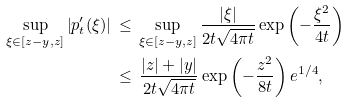Convert formula to latex. <formula><loc_0><loc_0><loc_500><loc_500>\sup _ { \xi \in [ z - y , z ] } \left | p _ { t } ^ { \prime } ( \xi ) \right | \, & \leq \, \sup _ { \xi \in [ z - y , z ] } \frac { | \xi | } { 2 t \sqrt { 4 \pi t } } \exp \left ( - \frac { \xi ^ { 2 } } { 4 t } \right ) \\ & \leq \, \frac { | z | + | y | } { 2 t \sqrt { 4 \pi t } } \exp \left ( - \frac { z ^ { 2 } } { 8 t } \right ) e ^ { 1 / 4 } ,</formula> 